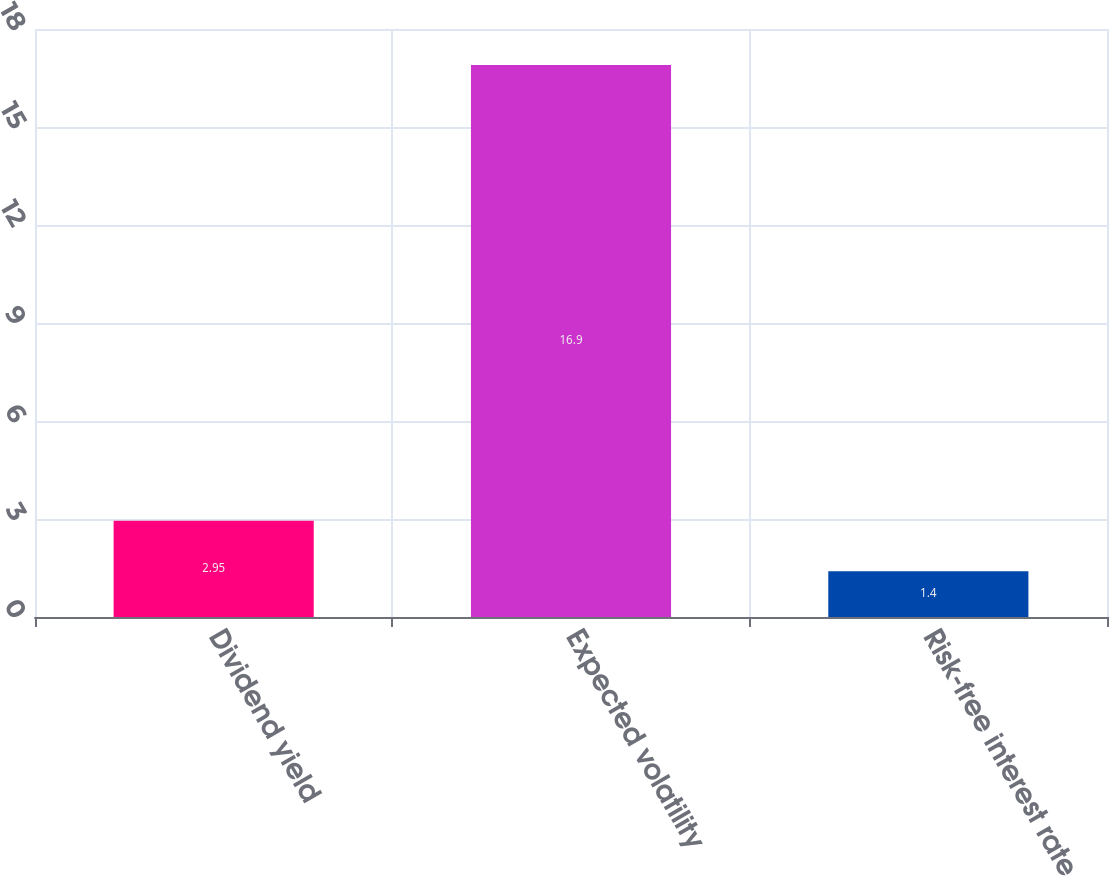<chart> <loc_0><loc_0><loc_500><loc_500><bar_chart><fcel>Dividend yield<fcel>Expected volatility<fcel>Risk-free interest rate<nl><fcel>2.95<fcel>16.9<fcel>1.4<nl></chart> 